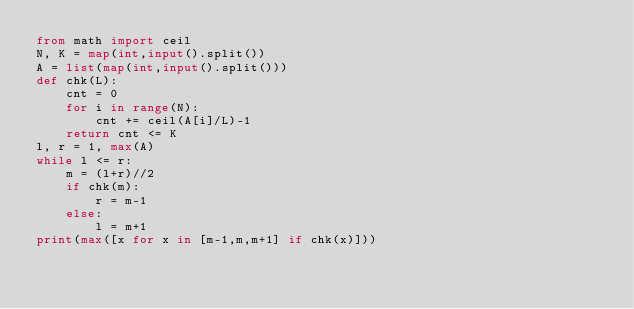Convert code to text. <code><loc_0><loc_0><loc_500><loc_500><_Python_>from math import ceil
N, K = map(int,input().split())
A = list(map(int,input().split()))
def chk(L):
    cnt = 0
    for i in range(N):
        cnt += ceil(A[i]/L)-1
    return cnt <= K
l, r = 1, max(A)
while l <= r:
    m = (l+r)//2
    if chk(m):
        r = m-1
    else:
        l = m+1
print(max([x for x in [m-1,m,m+1] if chk(x)]))</code> 